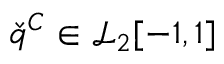<formula> <loc_0><loc_0><loc_500><loc_500>\check { q } ^ { C } \in \mathcal { L } _ { 2 } [ - 1 , 1 ]</formula> 